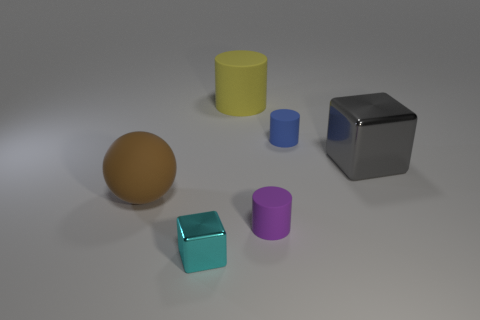Subtract all small purple cylinders. How many cylinders are left? 2 Add 3 large yellow things. How many objects exist? 9 Subtract all yellow cylinders. How many cylinders are left? 2 Subtract all cyan cylinders. How many blue cubes are left? 0 Subtract all big rubber objects. Subtract all purple cubes. How many objects are left? 4 Add 4 shiny blocks. How many shiny blocks are left? 6 Add 5 large spheres. How many large spheres exist? 6 Subtract 0 yellow cubes. How many objects are left? 6 Subtract all cubes. How many objects are left? 4 Subtract 1 cylinders. How many cylinders are left? 2 